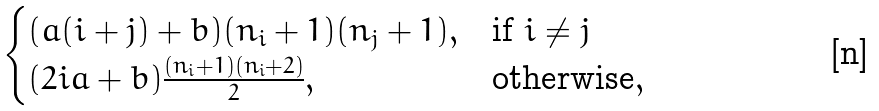<formula> <loc_0><loc_0><loc_500><loc_500>\begin{cases} ( a ( i + j ) + b ) ( n _ { i } + 1 ) ( n _ { j } + 1 ) , & \text {if} \ i \neq j \\ ( 2 i a + b ) \frac { ( n _ { i } + 1 ) ( n _ { i } + 2 ) } { 2 } , & \text {otherwise} , \end{cases}</formula> 